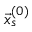<formula> <loc_0><loc_0><loc_500><loc_500>\vec { x } _ { s } ^ { ( 0 ) }</formula> 